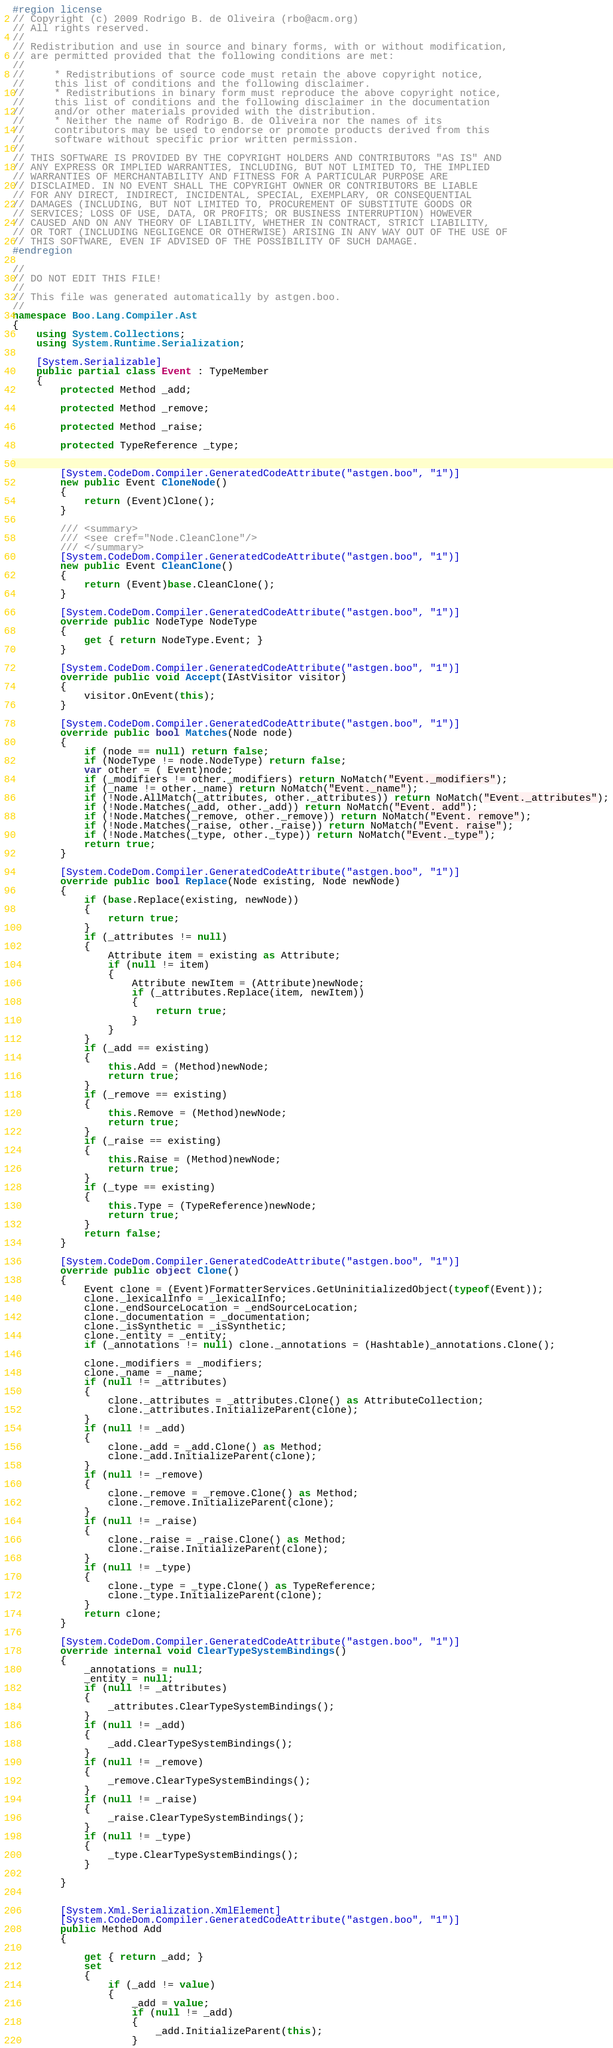Convert code to text. <code><loc_0><loc_0><loc_500><loc_500><_C#_>#region license
// Copyright (c) 2009 Rodrigo B. de Oliveira (rbo@acm.org)
// All rights reserved.
// 
// Redistribution and use in source and binary forms, with or without modification,
// are permitted provided that the following conditions are met:
// 
//     * Redistributions of source code must retain the above copyright notice,
//     this list of conditions and the following disclaimer.
//     * Redistributions in binary form must reproduce the above copyright notice,
//     this list of conditions and the following disclaimer in the documentation
//     and/or other materials provided with the distribution.
//     * Neither the name of Rodrigo B. de Oliveira nor the names of its
//     contributors may be used to endorse or promote products derived from this
//     software without specific prior written permission.
// 
// THIS SOFTWARE IS PROVIDED BY THE COPYRIGHT HOLDERS AND CONTRIBUTORS "AS IS" AND
// ANY EXPRESS OR IMPLIED WARRANTIES, INCLUDING, BUT NOT LIMITED TO, THE IMPLIED
// WARRANTIES OF MERCHANTABILITY AND FITNESS FOR A PARTICULAR PURPOSE ARE
// DISCLAIMED. IN NO EVENT SHALL THE COPYRIGHT OWNER OR CONTRIBUTORS BE LIABLE
// FOR ANY DIRECT, INDIRECT, INCIDENTAL, SPECIAL, EXEMPLARY, OR CONSEQUENTIAL
// DAMAGES (INCLUDING, BUT NOT LIMITED TO, PROCUREMENT OF SUBSTITUTE GOODS OR
// SERVICES; LOSS OF USE, DATA, OR PROFITS; OR BUSINESS INTERRUPTION) HOWEVER
// CAUSED AND ON ANY THEORY OF LIABILITY, WHETHER IN CONTRACT, STRICT LIABILITY,
// OR TORT (INCLUDING NEGLIGENCE OR OTHERWISE) ARISING IN ANY WAY OUT OF THE USE OF
// THIS SOFTWARE, EVEN IF ADVISED OF THE POSSIBILITY OF SUCH DAMAGE.
#endregion

//
// DO NOT EDIT THIS FILE!
//
// This file was generated automatically by astgen.boo.
//
namespace Boo.Lang.Compiler.Ast
{	
	using System.Collections;
	using System.Runtime.Serialization;
	
	[System.Serializable]
	public partial class Event : TypeMember
	{
		protected Method _add;

		protected Method _remove;

		protected Method _raise;

		protected TypeReference _type;


		[System.CodeDom.Compiler.GeneratedCodeAttribute("astgen.boo", "1")]
		new public Event CloneNode()
		{
			return (Event)Clone();
		}
		
		/// <summary>
		/// <see cref="Node.CleanClone"/>
		/// </summary>
		[System.CodeDom.Compiler.GeneratedCodeAttribute("astgen.boo", "1")]
		new public Event CleanClone()
		{
			return (Event)base.CleanClone();
		}

		[System.CodeDom.Compiler.GeneratedCodeAttribute("astgen.boo", "1")]
		override public NodeType NodeType
		{
			get { return NodeType.Event; }
		}

		[System.CodeDom.Compiler.GeneratedCodeAttribute("astgen.boo", "1")]
		override public void Accept(IAstVisitor visitor)
		{
			visitor.OnEvent(this);
		}

		[System.CodeDom.Compiler.GeneratedCodeAttribute("astgen.boo", "1")]
		override public bool Matches(Node node)
		{	
			if (node == null) return false;
			if (NodeType != node.NodeType) return false;
			var other = ( Event)node;
			if (_modifiers != other._modifiers) return NoMatch("Event._modifiers");
			if (_name != other._name) return NoMatch("Event._name");
			if (!Node.AllMatch(_attributes, other._attributes)) return NoMatch("Event._attributes");
			if (!Node.Matches(_add, other._add)) return NoMatch("Event._add");
			if (!Node.Matches(_remove, other._remove)) return NoMatch("Event._remove");
			if (!Node.Matches(_raise, other._raise)) return NoMatch("Event._raise");
			if (!Node.Matches(_type, other._type)) return NoMatch("Event._type");
			return true;
		}

		[System.CodeDom.Compiler.GeneratedCodeAttribute("astgen.boo", "1")]
		override public bool Replace(Node existing, Node newNode)
		{
			if (base.Replace(existing, newNode))
			{
				return true;
			}
			if (_attributes != null)
			{
				Attribute item = existing as Attribute;
				if (null != item)
				{
					Attribute newItem = (Attribute)newNode;
					if (_attributes.Replace(item, newItem))
					{
						return true;
					}
				}
			}
			if (_add == existing)
			{
				this.Add = (Method)newNode;
				return true;
			}
			if (_remove == existing)
			{
				this.Remove = (Method)newNode;
				return true;
			}
			if (_raise == existing)
			{
				this.Raise = (Method)newNode;
				return true;
			}
			if (_type == existing)
			{
				this.Type = (TypeReference)newNode;
				return true;
			}
			return false;
		}

		[System.CodeDom.Compiler.GeneratedCodeAttribute("astgen.boo", "1")]
		override public object Clone()
		{
			Event clone = (Event)FormatterServices.GetUninitializedObject(typeof(Event));
			clone._lexicalInfo = _lexicalInfo;
			clone._endSourceLocation = _endSourceLocation;
			clone._documentation = _documentation;
			clone._isSynthetic = _isSynthetic;
			clone._entity = _entity;
			if (_annotations != null) clone._annotations = (Hashtable)_annotations.Clone();
		
			clone._modifiers = _modifiers;
			clone._name = _name;
			if (null != _attributes)
			{
				clone._attributes = _attributes.Clone() as AttributeCollection;
				clone._attributes.InitializeParent(clone);
			}
			if (null != _add)
			{
				clone._add = _add.Clone() as Method;
				clone._add.InitializeParent(clone);
			}
			if (null != _remove)
			{
				clone._remove = _remove.Clone() as Method;
				clone._remove.InitializeParent(clone);
			}
			if (null != _raise)
			{
				clone._raise = _raise.Clone() as Method;
				clone._raise.InitializeParent(clone);
			}
			if (null != _type)
			{
				clone._type = _type.Clone() as TypeReference;
				clone._type.InitializeParent(clone);
			}
			return clone;
		}

		[System.CodeDom.Compiler.GeneratedCodeAttribute("astgen.boo", "1")]
		override internal void ClearTypeSystemBindings()
		{
			_annotations = null;
			_entity = null;
			if (null != _attributes)
			{
				_attributes.ClearTypeSystemBindings();
			}
			if (null != _add)
			{
				_add.ClearTypeSystemBindings();
			}
			if (null != _remove)
			{
				_remove.ClearTypeSystemBindings();
			}
			if (null != _raise)
			{
				_raise.ClearTypeSystemBindings();
			}
			if (null != _type)
			{
				_type.ClearTypeSystemBindings();
			}

		}
	

		[System.Xml.Serialization.XmlElement]
		[System.CodeDom.Compiler.GeneratedCodeAttribute("astgen.boo", "1")]
		public Method Add
		{
			
			get { return _add; }
			set
			{
				if (_add != value)
				{
					_add = value;
					if (null != _add)
					{
						_add.InitializeParent(this);
					}</code> 